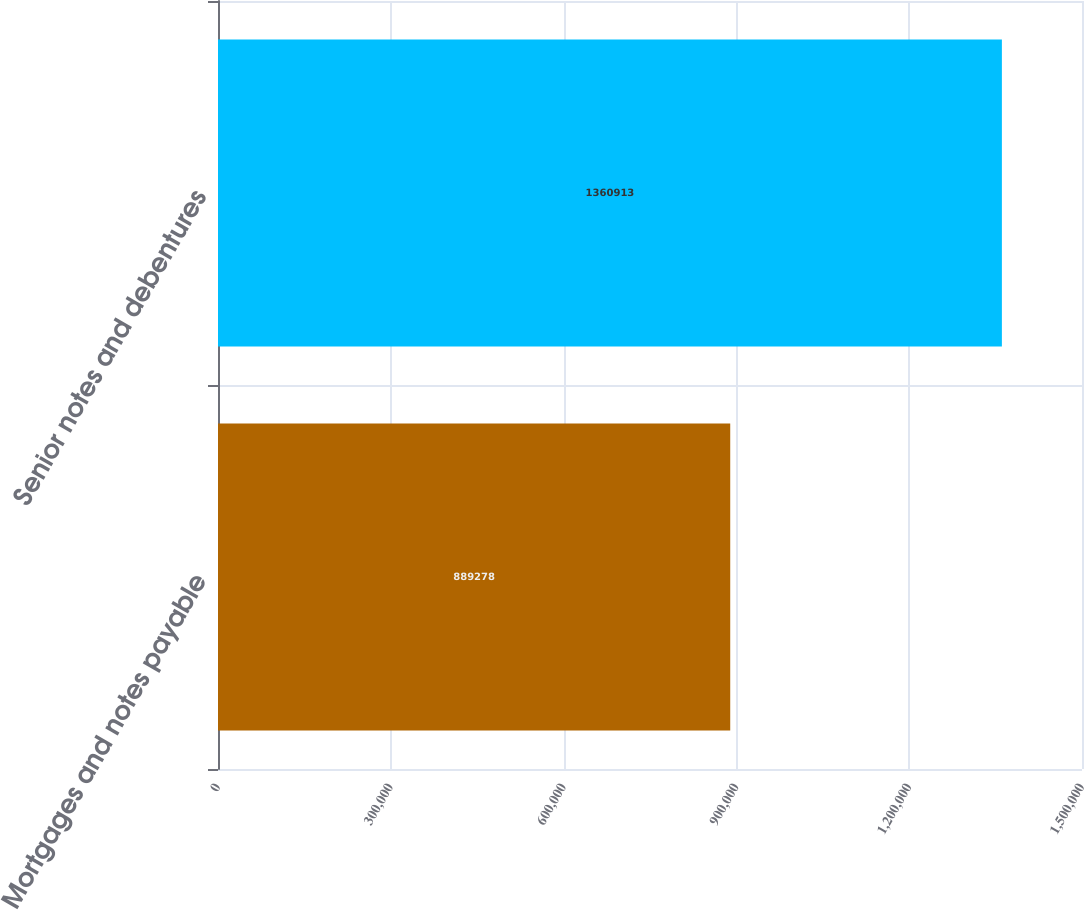Convert chart to OTSL. <chart><loc_0><loc_0><loc_500><loc_500><bar_chart><fcel>Mortgages and notes payable<fcel>Senior notes and debentures<nl><fcel>889278<fcel>1.36091e+06<nl></chart> 